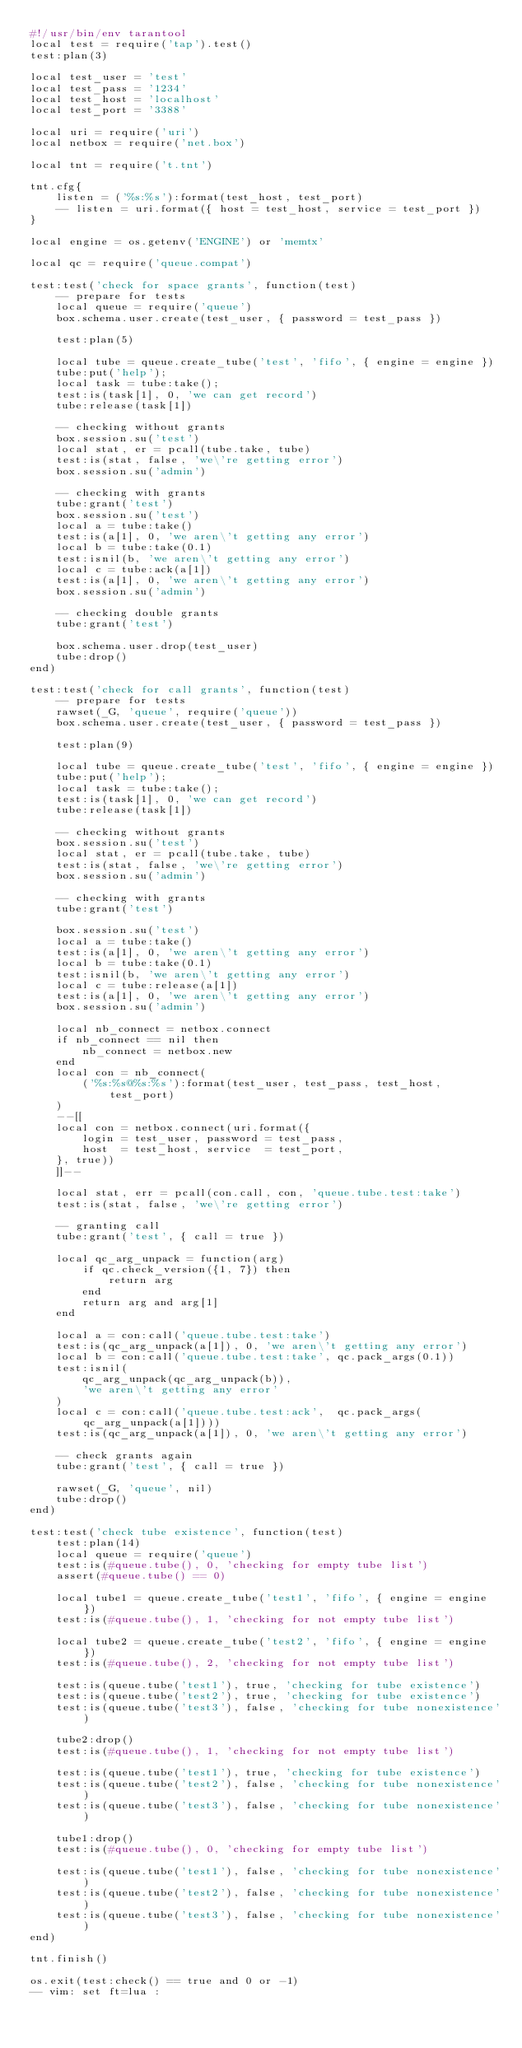Convert code to text. <code><loc_0><loc_0><loc_500><loc_500><_Perl_>#!/usr/bin/env tarantool
local test = require('tap').test()
test:plan(3)

local test_user = 'test'
local test_pass = '1234'
local test_host = 'localhost'
local test_port = '3388'

local uri = require('uri')
local netbox = require('net.box')

local tnt = require('t.tnt')

tnt.cfg{
    listen = ('%s:%s'):format(test_host, test_port)
    -- listen = uri.format({ host = test_host, service = test_port })
}

local engine = os.getenv('ENGINE') or 'memtx'

local qc = require('queue.compat')

test:test('check for space grants', function(test)
    -- prepare for tests
    local queue = require('queue')
    box.schema.user.create(test_user, { password = test_pass })

    test:plan(5)

    local tube = queue.create_tube('test', 'fifo', { engine = engine })
    tube:put('help');
    local task = tube:take();
    test:is(task[1], 0, 'we can get record')
    tube:release(task[1])

    -- checking without grants
    box.session.su('test')
    local stat, er = pcall(tube.take, tube)
    test:is(stat, false, 'we\'re getting error')
    box.session.su('admin')

    -- checking with grants
    tube:grant('test')
    box.session.su('test')
    local a = tube:take()
    test:is(a[1], 0, 'we aren\'t getting any error')
    local b = tube:take(0.1)
    test:isnil(b, 'we aren\'t getting any error')
    local c = tube:ack(a[1])
    test:is(a[1], 0, 'we aren\'t getting any error')
    box.session.su('admin')

    -- checking double grants
    tube:grant('test')

    box.schema.user.drop(test_user)
    tube:drop()
end)

test:test('check for call grants', function(test)
    -- prepare for tests
    rawset(_G, 'queue', require('queue'))
    box.schema.user.create(test_user, { password = test_pass })

    test:plan(9)

    local tube = queue.create_tube('test', 'fifo', { engine = engine })
    tube:put('help');
    local task = tube:take();
    test:is(task[1], 0, 'we can get record')
    tube:release(task[1])

    -- checking without grants
    box.session.su('test')
    local stat, er = pcall(tube.take, tube)
    test:is(stat, false, 'we\'re getting error')
    box.session.su('admin')

    -- checking with grants
    tube:grant('test')

    box.session.su('test')
    local a = tube:take()
    test:is(a[1], 0, 'we aren\'t getting any error')
    local b = tube:take(0.1)
    test:isnil(b, 'we aren\'t getting any error')
    local c = tube:release(a[1])
    test:is(a[1], 0, 'we aren\'t getting any error')
    box.session.su('admin')

    local nb_connect = netbox.connect
    if nb_connect == nil then
        nb_connect = netbox.new
    end
    local con = nb_connect(
        ('%s:%s@%s:%s'):format(test_user, test_pass, test_host, test_port)
    )
    --[[
    local con = netbox.connect(uri.format({
        login = test_user, password = test_pass,
        host  = test_host, service  = test_port,
    }, true))
    ]]--

    local stat, err = pcall(con.call, con, 'queue.tube.test:take')
    test:is(stat, false, 'we\'re getting error')

    -- granting call
    tube:grant('test', { call = true })

    local qc_arg_unpack = function(arg)
        if qc.check_version({1, 7}) then
            return arg
        end
        return arg and arg[1]
    end

    local a = con:call('queue.tube.test:take')
    test:is(qc_arg_unpack(a[1]), 0, 'we aren\'t getting any error')
    local b = con:call('queue.tube.test:take', qc.pack_args(0.1))
    test:isnil(
        qc_arg_unpack(qc_arg_unpack(b)),
        'we aren\'t getting any error'
    )
    local c = con:call('queue.tube.test:ack',  qc.pack_args(qc_arg_unpack(a[1])))
    test:is(qc_arg_unpack(a[1]), 0, 'we aren\'t getting any error')

    -- check grants again
    tube:grant('test', { call = true })

    rawset(_G, 'queue', nil)
    tube:drop()
end)

test:test('check tube existence', function(test)
    test:plan(14)
    local queue = require('queue')
    test:is(#queue.tube(), 0, 'checking for empty tube list')
    assert(#queue.tube() == 0)

    local tube1 = queue.create_tube('test1', 'fifo', { engine = engine })
    test:is(#queue.tube(), 1, 'checking for not empty tube list')

    local tube2 = queue.create_tube('test2', 'fifo', { engine = engine })
    test:is(#queue.tube(), 2, 'checking for not empty tube list')

    test:is(queue.tube('test1'), true, 'checking for tube existence')
    test:is(queue.tube('test2'), true, 'checking for tube existence')
    test:is(queue.tube('test3'), false, 'checking for tube nonexistence')

    tube2:drop()
    test:is(#queue.tube(), 1, 'checking for not empty tube list')

    test:is(queue.tube('test1'), true, 'checking for tube existence')
    test:is(queue.tube('test2'), false, 'checking for tube nonexistence')
    test:is(queue.tube('test3'), false, 'checking for tube nonexistence')

    tube1:drop()
    test:is(#queue.tube(), 0, 'checking for empty tube list')

    test:is(queue.tube('test1'), false, 'checking for tube nonexistence')
    test:is(queue.tube('test2'), false, 'checking for tube nonexistence')
    test:is(queue.tube('test3'), false, 'checking for tube nonexistence')
end)

tnt.finish()

os.exit(test:check() == true and 0 or -1)
-- vim: set ft=lua :
</code> 